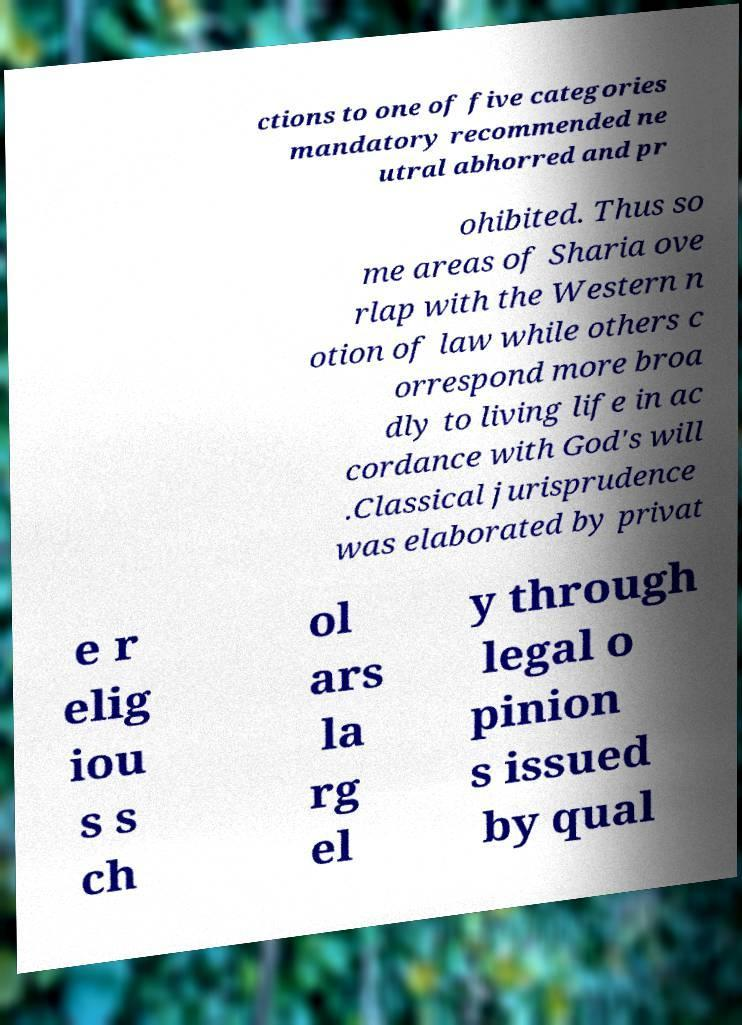Can you read and provide the text displayed in the image?This photo seems to have some interesting text. Can you extract and type it out for me? ctions to one of five categories mandatory recommended ne utral abhorred and pr ohibited. Thus so me areas of Sharia ove rlap with the Western n otion of law while others c orrespond more broa dly to living life in ac cordance with God's will .Classical jurisprudence was elaborated by privat e r elig iou s s ch ol ars la rg el y through legal o pinion s issued by qual 